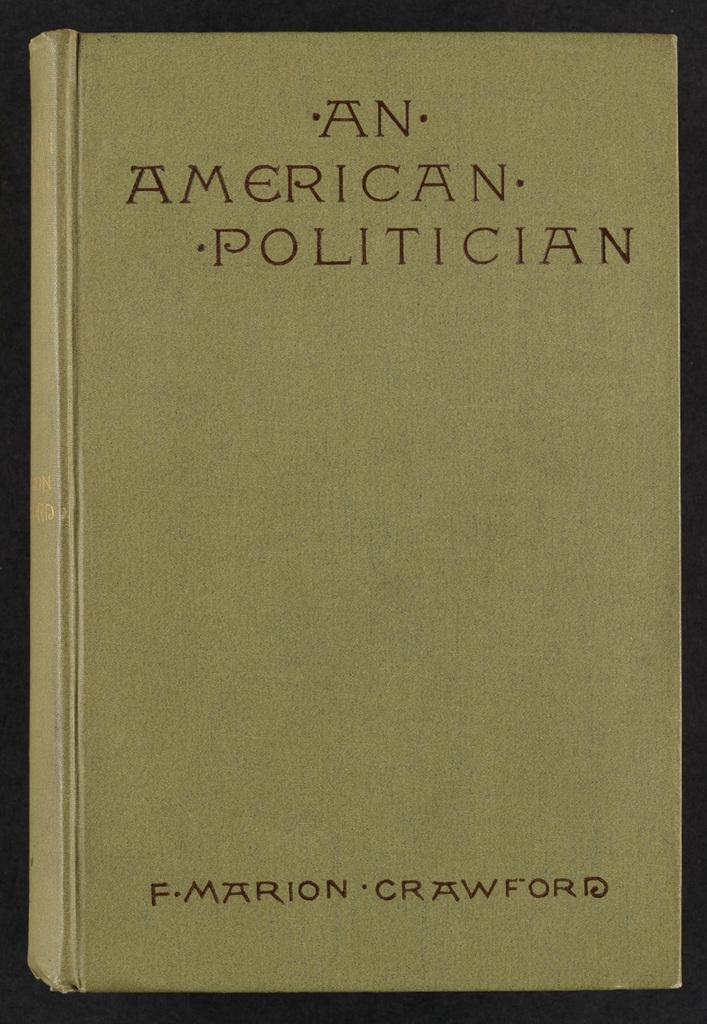<image>
Provide a brief description of the given image. A yellow book cover titled An American Politician. 